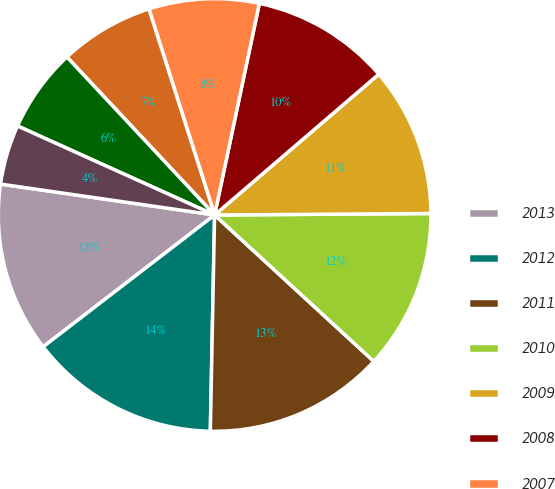Convert chart. <chart><loc_0><loc_0><loc_500><loc_500><pie_chart><fcel>2013<fcel>2012<fcel>2011<fcel>2010<fcel>2009<fcel>2008<fcel>2007<fcel>2006<fcel>2005<fcel>2004<nl><fcel>12.71%<fcel>14.25%<fcel>13.48%<fcel>11.94%<fcel>11.17%<fcel>10.4%<fcel>8.23%<fcel>7.05%<fcel>6.28%<fcel>4.47%<nl></chart> 